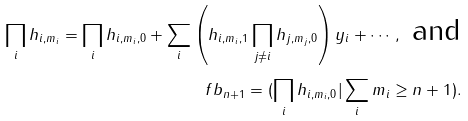<formula> <loc_0><loc_0><loc_500><loc_500>\prod _ { i } h _ { i , m _ { i } } = \prod _ { i } h _ { i , m _ { i } , 0 } + \sum _ { i } \left ( h _ { i , m _ { i } , 1 } \prod _ { j \ne i } h _ { j , m _ { j } , 0 } \right ) y _ { i } + \cdots , \text { and} \\ \ f b _ { n + 1 } = ( \prod _ { i } h _ { i , m _ { i } , 0 } | \sum _ { i } m _ { i } \geq n + 1 ) .</formula> 